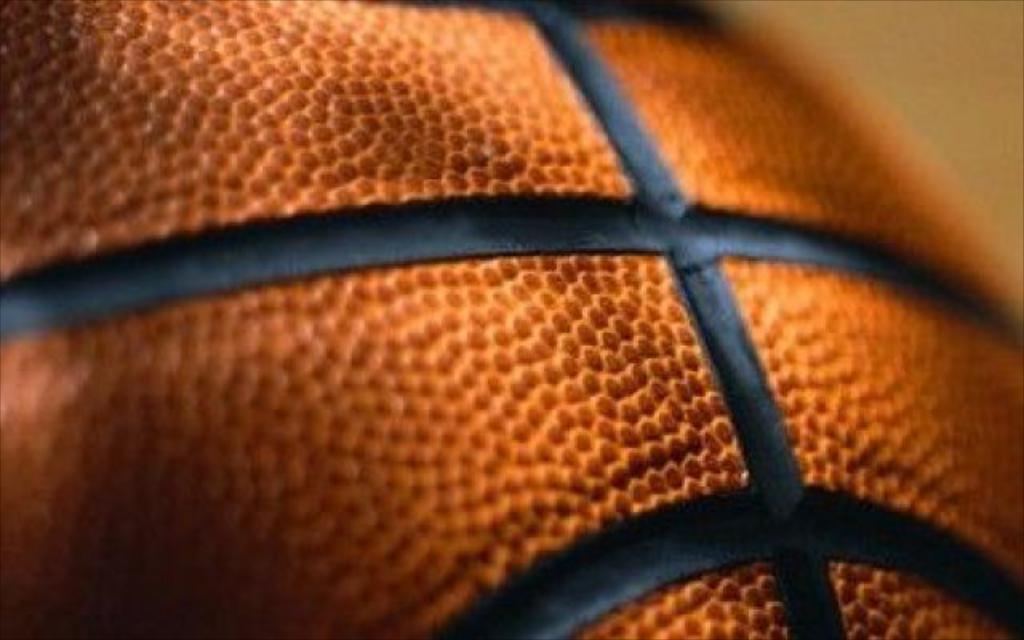In one or two sentences, can you explain what this image depicts? This is an image of a basketball. The background is blurry. 